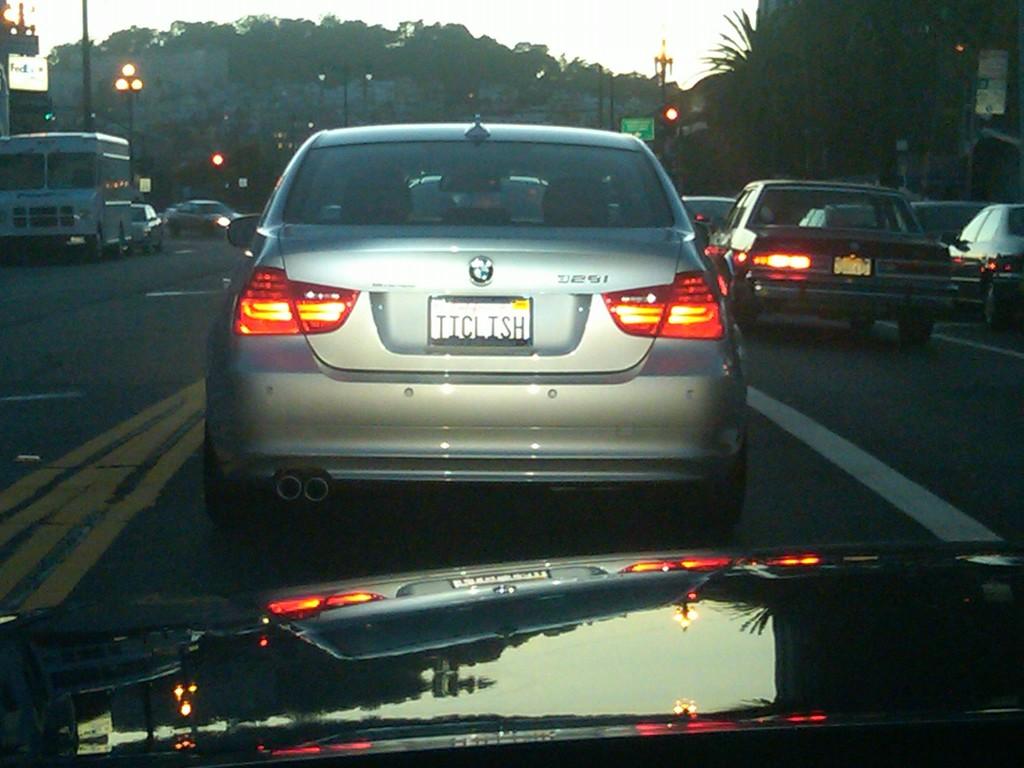What make of car is this?
Provide a succinct answer. Bmw. What does the license plate say?
Your answer should be very brief. Ticlish. 